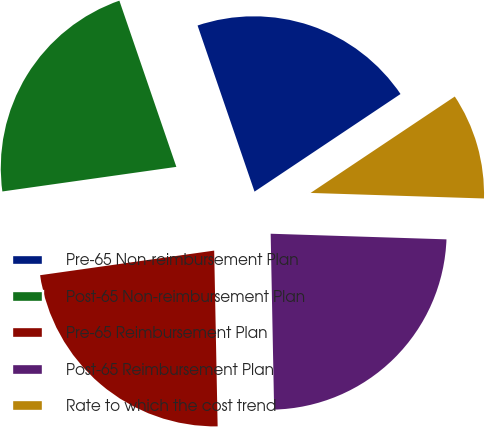Convert chart. <chart><loc_0><loc_0><loc_500><loc_500><pie_chart><fcel>Pre-65 Non-reimbursement Plan<fcel>Post-65 Non-reimbursement Plan<fcel>Pre-65 Reimbursement Plan<fcel>Post-65 Reimbursement Plan<fcel>Rate to which the cost trend<nl><fcel>20.88%<fcel>21.98%<fcel>23.08%<fcel>24.18%<fcel>9.89%<nl></chart> 